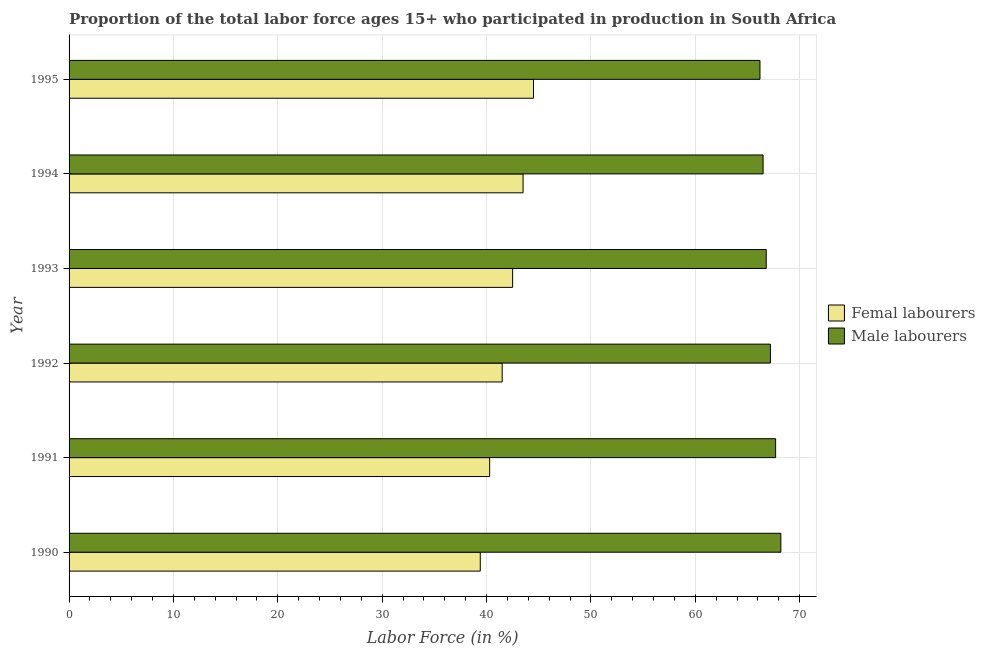How many groups of bars are there?
Offer a terse response. 6. Are the number of bars per tick equal to the number of legend labels?
Your response must be concise. Yes. Are the number of bars on each tick of the Y-axis equal?
Give a very brief answer. Yes. How many bars are there on the 4th tick from the bottom?
Your answer should be very brief. 2. What is the label of the 5th group of bars from the top?
Provide a succinct answer. 1991. In how many cases, is the number of bars for a given year not equal to the number of legend labels?
Offer a terse response. 0. What is the percentage of male labour force in 1995?
Provide a short and direct response. 66.2. Across all years, what is the maximum percentage of male labour force?
Keep it short and to the point. 68.2. Across all years, what is the minimum percentage of female labor force?
Ensure brevity in your answer.  39.4. In which year was the percentage of female labor force minimum?
Provide a succinct answer. 1990. What is the total percentage of male labour force in the graph?
Provide a short and direct response. 402.6. What is the difference between the percentage of female labor force in 1990 and that in 1995?
Your response must be concise. -5.1. What is the difference between the percentage of female labor force in 1991 and the percentage of male labour force in 1990?
Your answer should be compact. -27.9. What is the average percentage of male labour force per year?
Your answer should be compact. 67.1. In the year 1993, what is the difference between the percentage of female labor force and percentage of male labour force?
Keep it short and to the point. -24.3. In how many years, is the percentage of male labour force greater than 36 %?
Make the answer very short. 6. Is the percentage of female labor force in 1992 less than that in 1993?
Provide a succinct answer. Yes. In how many years, is the percentage of female labor force greater than the average percentage of female labor force taken over all years?
Your answer should be very brief. 3. What does the 2nd bar from the top in 1991 represents?
Provide a succinct answer. Femal labourers. What does the 2nd bar from the bottom in 1991 represents?
Offer a very short reply. Male labourers. What is the difference between two consecutive major ticks on the X-axis?
Keep it short and to the point. 10. Are the values on the major ticks of X-axis written in scientific E-notation?
Offer a very short reply. No. Does the graph contain any zero values?
Keep it short and to the point. No. Does the graph contain grids?
Offer a very short reply. Yes. How many legend labels are there?
Offer a terse response. 2. What is the title of the graph?
Your answer should be compact. Proportion of the total labor force ages 15+ who participated in production in South Africa. Does "Foreign liabilities" appear as one of the legend labels in the graph?
Your answer should be compact. No. What is the Labor Force (in %) of Femal labourers in 1990?
Offer a very short reply. 39.4. What is the Labor Force (in %) of Male labourers in 1990?
Keep it short and to the point. 68.2. What is the Labor Force (in %) of Femal labourers in 1991?
Your response must be concise. 40.3. What is the Labor Force (in %) of Male labourers in 1991?
Provide a succinct answer. 67.7. What is the Labor Force (in %) in Femal labourers in 1992?
Your answer should be compact. 41.5. What is the Labor Force (in %) in Male labourers in 1992?
Offer a terse response. 67.2. What is the Labor Force (in %) of Femal labourers in 1993?
Your answer should be compact. 42.5. What is the Labor Force (in %) of Male labourers in 1993?
Your answer should be compact. 66.8. What is the Labor Force (in %) of Femal labourers in 1994?
Your response must be concise. 43.5. What is the Labor Force (in %) in Male labourers in 1994?
Offer a terse response. 66.5. What is the Labor Force (in %) of Femal labourers in 1995?
Your response must be concise. 44.5. What is the Labor Force (in %) in Male labourers in 1995?
Keep it short and to the point. 66.2. Across all years, what is the maximum Labor Force (in %) in Femal labourers?
Make the answer very short. 44.5. Across all years, what is the maximum Labor Force (in %) of Male labourers?
Your answer should be compact. 68.2. Across all years, what is the minimum Labor Force (in %) of Femal labourers?
Ensure brevity in your answer.  39.4. Across all years, what is the minimum Labor Force (in %) in Male labourers?
Your answer should be very brief. 66.2. What is the total Labor Force (in %) of Femal labourers in the graph?
Ensure brevity in your answer.  251.7. What is the total Labor Force (in %) in Male labourers in the graph?
Offer a very short reply. 402.6. What is the difference between the Labor Force (in %) in Male labourers in 1990 and that in 1992?
Provide a succinct answer. 1. What is the difference between the Labor Force (in %) in Male labourers in 1990 and that in 1993?
Provide a short and direct response. 1.4. What is the difference between the Labor Force (in %) in Male labourers in 1990 and that in 1994?
Your response must be concise. 1.7. What is the difference between the Labor Force (in %) of Femal labourers in 1990 and that in 1995?
Give a very brief answer. -5.1. What is the difference between the Labor Force (in %) in Femal labourers in 1991 and that in 1992?
Your response must be concise. -1.2. What is the difference between the Labor Force (in %) of Femal labourers in 1991 and that in 1993?
Provide a short and direct response. -2.2. What is the difference between the Labor Force (in %) of Male labourers in 1991 and that in 1993?
Offer a very short reply. 0.9. What is the difference between the Labor Force (in %) of Male labourers in 1991 and that in 1995?
Provide a succinct answer. 1.5. What is the difference between the Labor Force (in %) in Femal labourers in 1992 and that in 1993?
Your answer should be compact. -1. What is the difference between the Labor Force (in %) of Male labourers in 1992 and that in 1993?
Offer a terse response. 0.4. What is the difference between the Labor Force (in %) of Femal labourers in 1992 and that in 1994?
Your response must be concise. -2. What is the difference between the Labor Force (in %) in Femal labourers in 1993 and that in 1994?
Provide a succinct answer. -1. What is the difference between the Labor Force (in %) of Male labourers in 1993 and that in 1994?
Offer a terse response. 0.3. What is the difference between the Labor Force (in %) in Femal labourers in 1994 and that in 1995?
Provide a short and direct response. -1. What is the difference between the Labor Force (in %) of Male labourers in 1994 and that in 1995?
Keep it short and to the point. 0.3. What is the difference between the Labor Force (in %) in Femal labourers in 1990 and the Labor Force (in %) in Male labourers in 1991?
Ensure brevity in your answer.  -28.3. What is the difference between the Labor Force (in %) in Femal labourers in 1990 and the Labor Force (in %) in Male labourers in 1992?
Give a very brief answer. -27.8. What is the difference between the Labor Force (in %) of Femal labourers in 1990 and the Labor Force (in %) of Male labourers in 1993?
Give a very brief answer. -27.4. What is the difference between the Labor Force (in %) in Femal labourers in 1990 and the Labor Force (in %) in Male labourers in 1994?
Keep it short and to the point. -27.1. What is the difference between the Labor Force (in %) in Femal labourers in 1990 and the Labor Force (in %) in Male labourers in 1995?
Keep it short and to the point. -26.8. What is the difference between the Labor Force (in %) of Femal labourers in 1991 and the Labor Force (in %) of Male labourers in 1992?
Give a very brief answer. -26.9. What is the difference between the Labor Force (in %) in Femal labourers in 1991 and the Labor Force (in %) in Male labourers in 1993?
Provide a short and direct response. -26.5. What is the difference between the Labor Force (in %) of Femal labourers in 1991 and the Labor Force (in %) of Male labourers in 1994?
Offer a very short reply. -26.2. What is the difference between the Labor Force (in %) in Femal labourers in 1991 and the Labor Force (in %) in Male labourers in 1995?
Provide a short and direct response. -25.9. What is the difference between the Labor Force (in %) of Femal labourers in 1992 and the Labor Force (in %) of Male labourers in 1993?
Give a very brief answer. -25.3. What is the difference between the Labor Force (in %) of Femal labourers in 1992 and the Labor Force (in %) of Male labourers in 1994?
Provide a short and direct response. -25. What is the difference between the Labor Force (in %) of Femal labourers in 1992 and the Labor Force (in %) of Male labourers in 1995?
Give a very brief answer. -24.7. What is the difference between the Labor Force (in %) of Femal labourers in 1993 and the Labor Force (in %) of Male labourers in 1995?
Give a very brief answer. -23.7. What is the difference between the Labor Force (in %) in Femal labourers in 1994 and the Labor Force (in %) in Male labourers in 1995?
Your answer should be compact. -22.7. What is the average Labor Force (in %) in Femal labourers per year?
Your response must be concise. 41.95. What is the average Labor Force (in %) in Male labourers per year?
Keep it short and to the point. 67.1. In the year 1990, what is the difference between the Labor Force (in %) of Femal labourers and Labor Force (in %) of Male labourers?
Make the answer very short. -28.8. In the year 1991, what is the difference between the Labor Force (in %) of Femal labourers and Labor Force (in %) of Male labourers?
Make the answer very short. -27.4. In the year 1992, what is the difference between the Labor Force (in %) in Femal labourers and Labor Force (in %) in Male labourers?
Provide a short and direct response. -25.7. In the year 1993, what is the difference between the Labor Force (in %) of Femal labourers and Labor Force (in %) of Male labourers?
Your answer should be compact. -24.3. In the year 1995, what is the difference between the Labor Force (in %) in Femal labourers and Labor Force (in %) in Male labourers?
Give a very brief answer. -21.7. What is the ratio of the Labor Force (in %) of Femal labourers in 1990 to that in 1991?
Keep it short and to the point. 0.98. What is the ratio of the Labor Force (in %) of Male labourers in 1990 to that in 1991?
Provide a succinct answer. 1.01. What is the ratio of the Labor Force (in %) in Femal labourers in 1990 to that in 1992?
Offer a terse response. 0.95. What is the ratio of the Labor Force (in %) of Male labourers in 1990 to that in 1992?
Offer a very short reply. 1.01. What is the ratio of the Labor Force (in %) in Femal labourers in 1990 to that in 1993?
Offer a very short reply. 0.93. What is the ratio of the Labor Force (in %) in Femal labourers in 1990 to that in 1994?
Your answer should be compact. 0.91. What is the ratio of the Labor Force (in %) of Male labourers in 1990 to that in 1994?
Your answer should be compact. 1.03. What is the ratio of the Labor Force (in %) in Femal labourers in 1990 to that in 1995?
Make the answer very short. 0.89. What is the ratio of the Labor Force (in %) in Male labourers in 1990 to that in 1995?
Make the answer very short. 1.03. What is the ratio of the Labor Force (in %) of Femal labourers in 1991 to that in 1992?
Provide a succinct answer. 0.97. What is the ratio of the Labor Force (in %) of Male labourers in 1991 to that in 1992?
Your answer should be compact. 1.01. What is the ratio of the Labor Force (in %) of Femal labourers in 1991 to that in 1993?
Give a very brief answer. 0.95. What is the ratio of the Labor Force (in %) in Male labourers in 1991 to that in 1993?
Provide a short and direct response. 1.01. What is the ratio of the Labor Force (in %) of Femal labourers in 1991 to that in 1994?
Offer a terse response. 0.93. What is the ratio of the Labor Force (in %) in Male labourers in 1991 to that in 1994?
Offer a terse response. 1.02. What is the ratio of the Labor Force (in %) of Femal labourers in 1991 to that in 1995?
Your response must be concise. 0.91. What is the ratio of the Labor Force (in %) of Male labourers in 1991 to that in 1995?
Your answer should be very brief. 1.02. What is the ratio of the Labor Force (in %) of Femal labourers in 1992 to that in 1993?
Give a very brief answer. 0.98. What is the ratio of the Labor Force (in %) of Femal labourers in 1992 to that in 1994?
Provide a short and direct response. 0.95. What is the ratio of the Labor Force (in %) in Male labourers in 1992 to that in 1994?
Provide a short and direct response. 1.01. What is the ratio of the Labor Force (in %) of Femal labourers in 1992 to that in 1995?
Offer a very short reply. 0.93. What is the ratio of the Labor Force (in %) in Male labourers in 1992 to that in 1995?
Provide a succinct answer. 1.02. What is the ratio of the Labor Force (in %) in Male labourers in 1993 to that in 1994?
Your response must be concise. 1. What is the ratio of the Labor Force (in %) of Femal labourers in 1993 to that in 1995?
Keep it short and to the point. 0.96. What is the ratio of the Labor Force (in %) of Male labourers in 1993 to that in 1995?
Your answer should be very brief. 1.01. What is the ratio of the Labor Force (in %) in Femal labourers in 1994 to that in 1995?
Offer a very short reply. 0.98. What is the difference between the highest and the lowest Labor Force (in %) of Femal labourers?
Your answer should be very brief. 5.1. What is the difference between the highest and the lowest Labor Force (in %) in Male labourers?
Offer a very short reply. 2. 